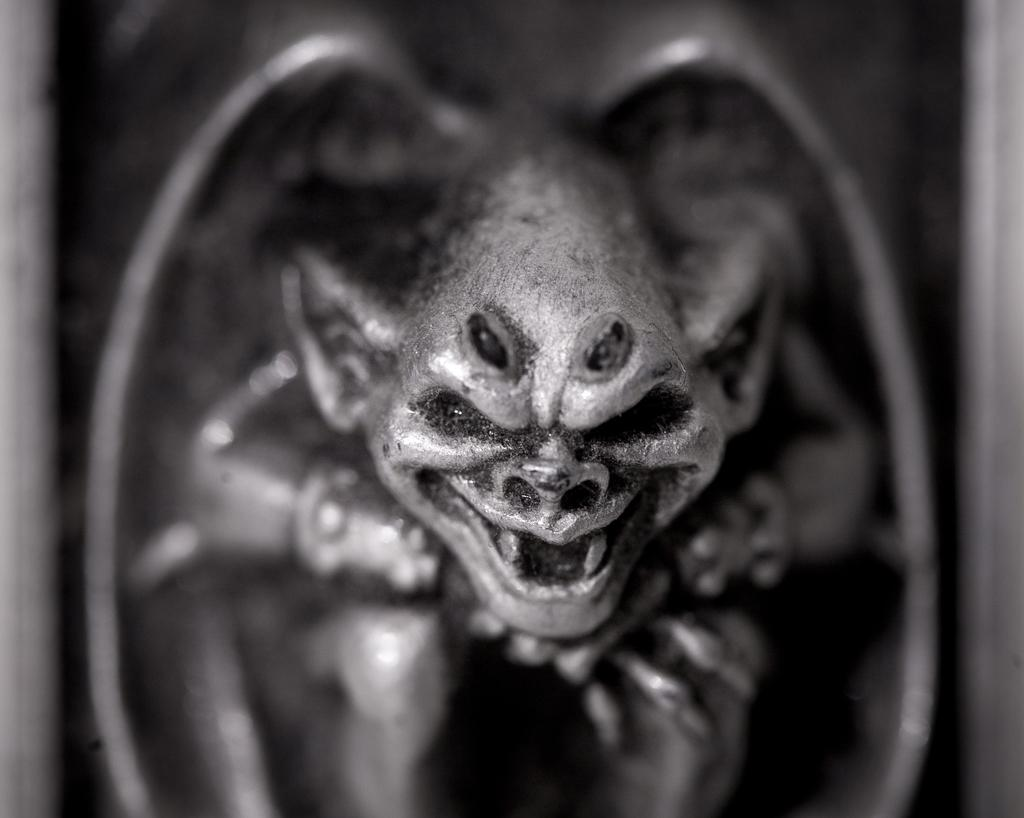What is the color scheme of the picture? The picture is black and white. What can be seen in the picture? There is a sculpture in the picture. What type of wren is perched on the sculpture in the image? There is no wren present in the image; it only features a sculpture in a black and white picture. 